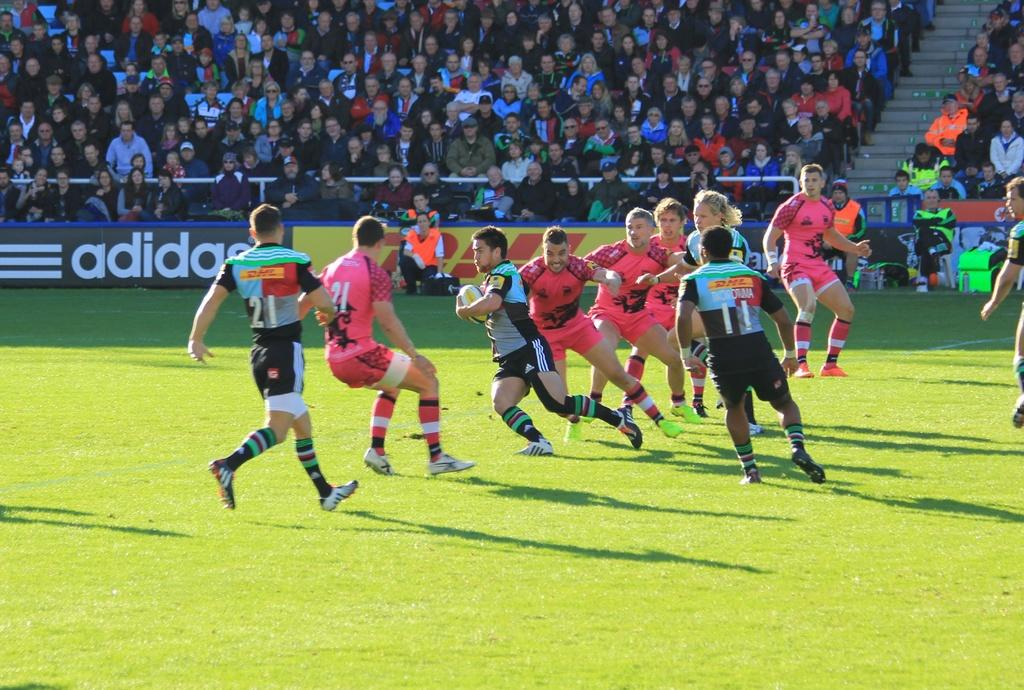Provide a one-sentence caption for the provided image. A player in a multi color jersey with the number 21 goes after a player in a pink jersey also with the number 21. 